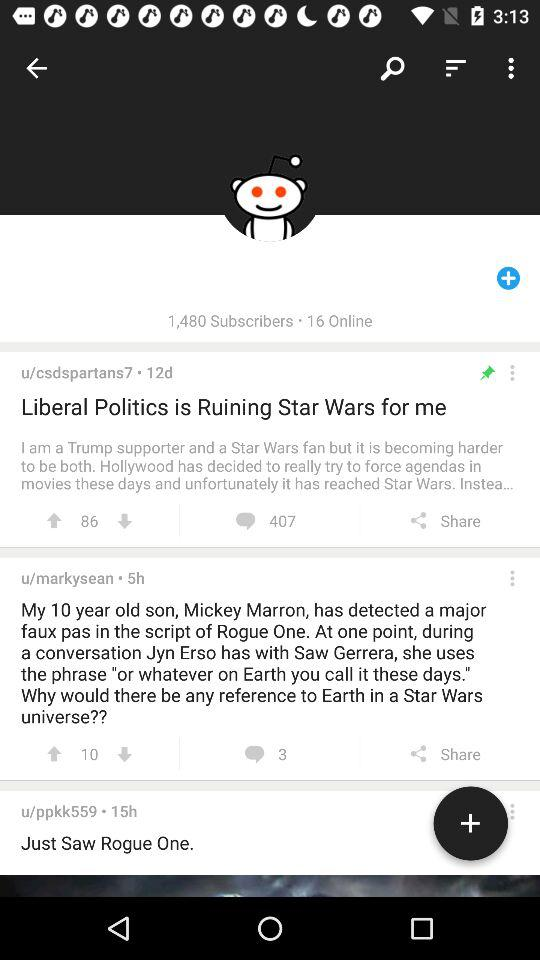How many comments are there for "Liberal Politics is Ruining Star Wars for Me"? There are 407 comments. 